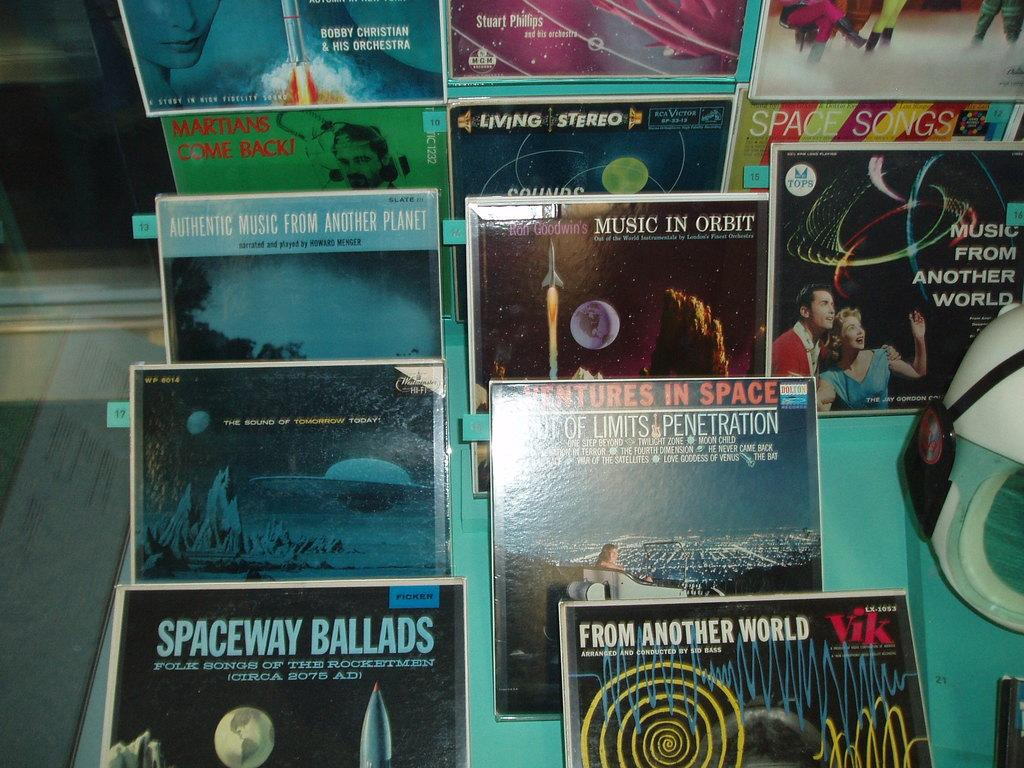<image>
Provide a brief description of the given image. A shelf has lots of vinyl records and one of them says Spaceway Ballads. 